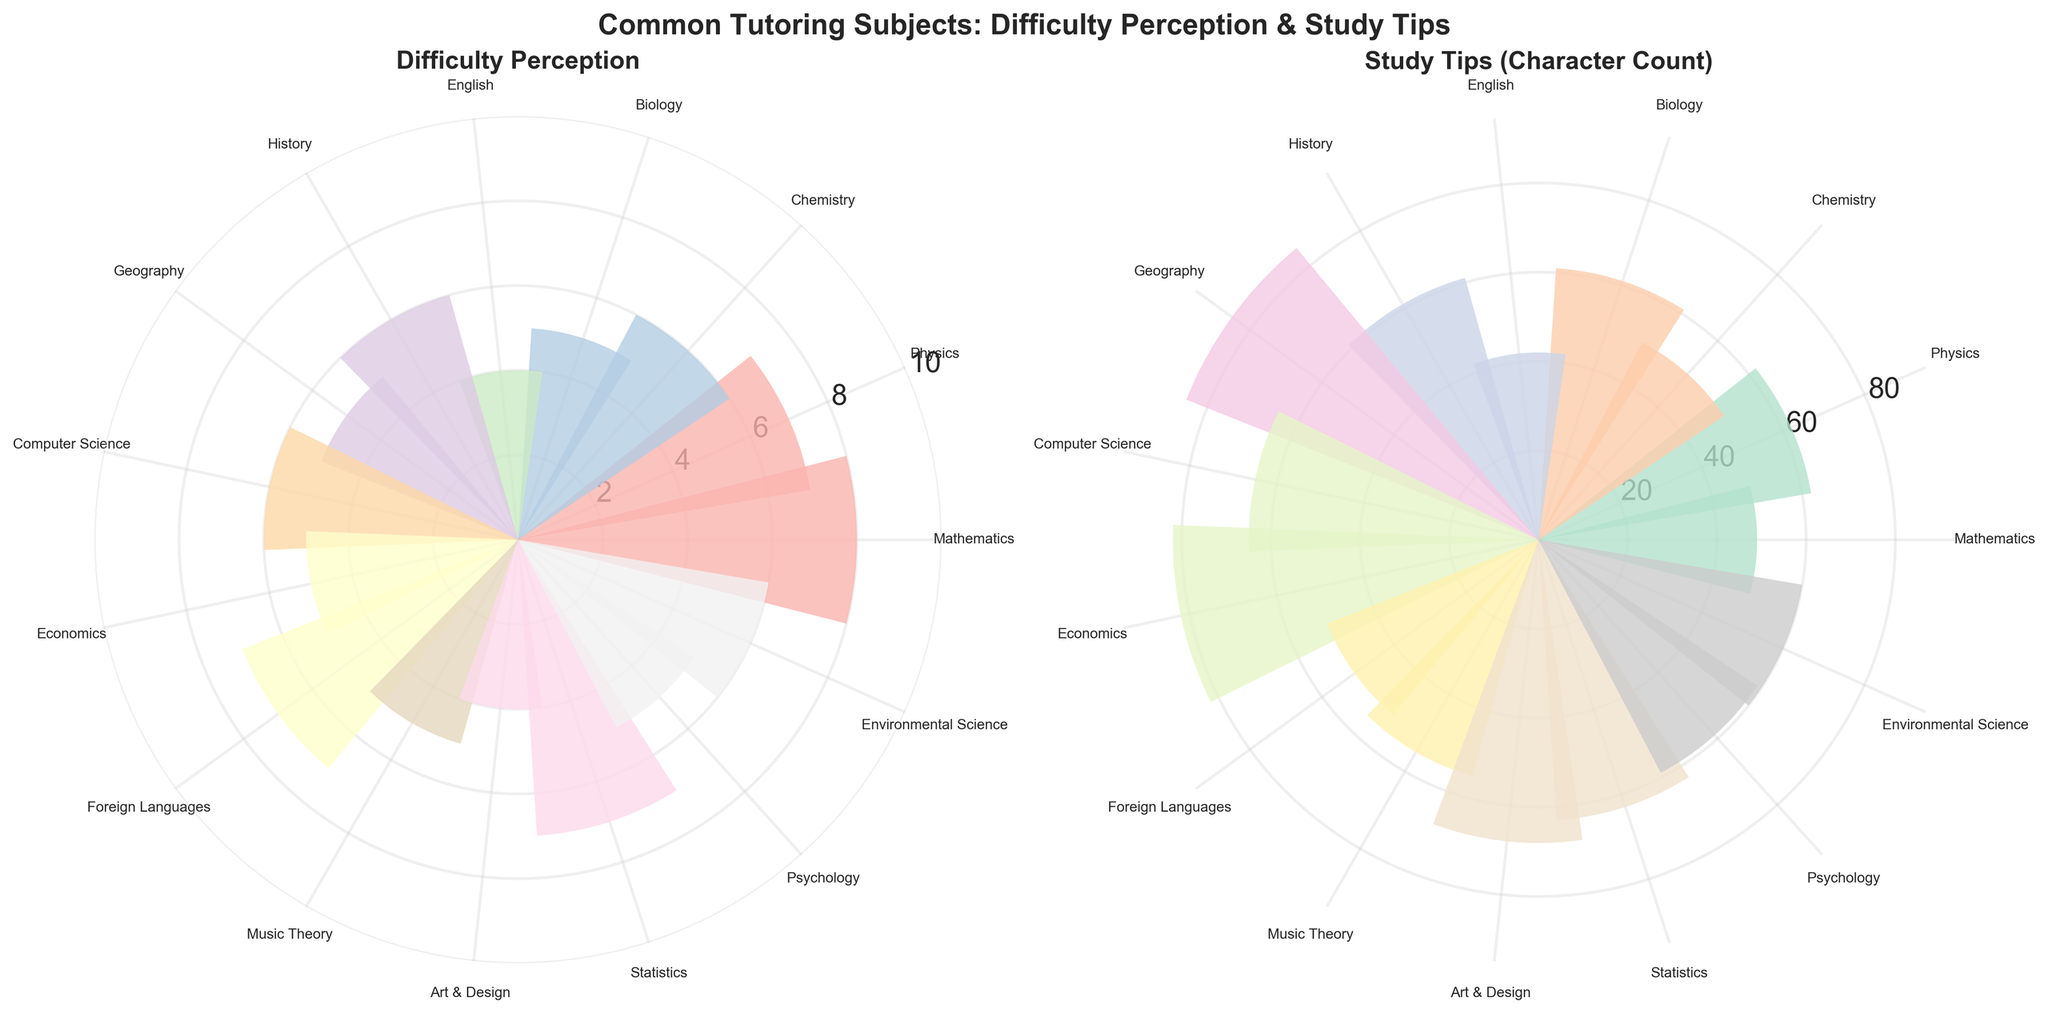What subject has the highest difficulty perception? By looking at the first rose chart titled "Difficulty Perception", the bar that extends furthest from the center represents the highest difficulty perception. That is for Mathematics, which reaches difficulty level 8.
Answer: Mathematics Which subjects have a difficulty perception higher than 6? In the first rose chart, bars reaching or extending beyond the level 7 circle should be examined. These subjects are Mathematics, Physics, Foreign Languages, and Statistics, which have difficulty perceptions of 8, 7, 7, and 7 respectively.
Answer: Mathematics, Physics, Foreign Languages, Statistics What's the difference in difficulty perception between Biology and Chemistry? In the first rose chart, the bar for Biology reaches difficulty level 5, and the bar for Chemistry reaches level 6. The difference is calculated as 6 - 5.
Answer: 1 Which subject has the shortest study tip character count? By looking at the second rose chart titled "Study Tips (Character Count)", the bar that is shortest represents the shortest character count. This is for English.
Answer: English Compare the difficulty perception and study tip character count for Physics. Are they proportional? In the first chart, the bar for Physics shows a difficulty perception of 7. In the second chart, the bar for Physics is rather long, indicating a high character count for study tips. While this suggests somewhat of a proportional relationship, it's not directly quantifiable from the chart whether they are exactly proportional.
Answer: Yes, somewhat proportional What study tip character count value lies in the middle of the range? The maximum character count observed in the second rose chart is around 70 (Mathematics) and the minimum is close to 20 (English). The middle value would be approximately the average of these extremes (70 + 20) / 2 = 45.
Answer: 45 What is the correlation between difficulty perception and study tip count for Computer Science? Both charts must be examined. The first chart places Computer Science at a difficulty level of 6. Refer to the second chart, where Computer Science shows a medium character count for study tips, indicating no directly obvious correlation from visual inspection alone.
Answer: Medium difficulty and medium study tips Which subject has equal difficulty perception and character count approximately around 40 in Study Tips? By checking both charts, we find that Chemistry has a difficulty perception of 6 and a relatively long bar in the Study Tips chart (about the mid-range). This character count is around 40, indicating a rough equivalence.
Answer: Chemistry 